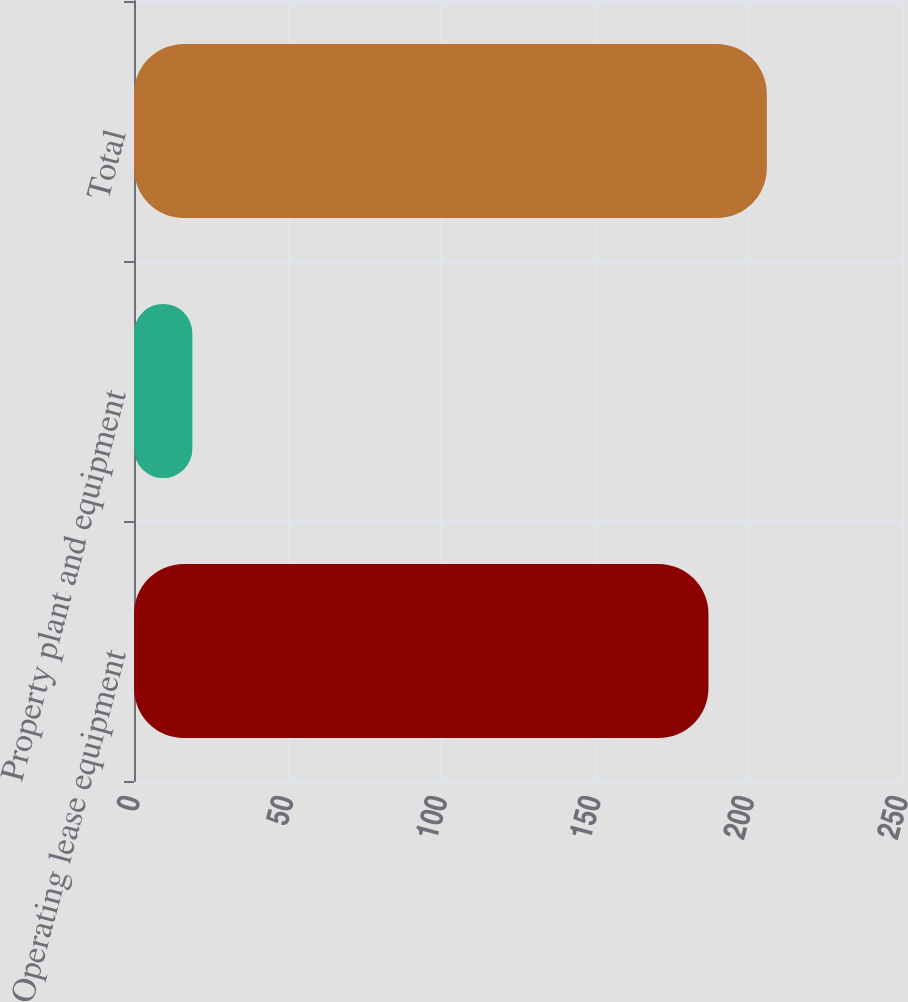Convert chart. <chart><loc_0><loc_0><loc_500><loc_500><bar_chart><fcel>Operating lease equipment<fcel>Property plant and equipment<fcel>Total<nl><fcel>187<fcel>19<fcel>206<nl></chart> 